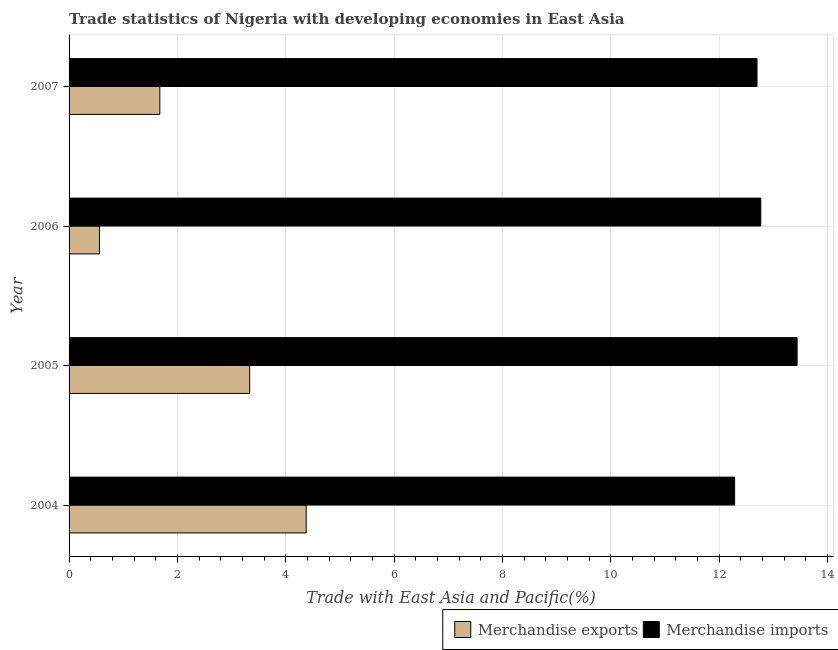How many different coloured bars are there?
Your answer should be compact. 2. How many groups of bars are there?
Provide a succinct answer. 4. Are the number of bars on each tick of the Y-axis equal?
Your answer should be very brief. Yes. How many bars are there on the 1st tick from the top?
Your response must be concise. 2. What is the merchandise imports in 2006?
Your answer should be very brief. 12.77. Across all years, what is the maximum merchandise exports?
Provide a succinct answer. 4.38. Across all years, what is the minimum merchandise imports?
Ensure brevity in your answer.  12.28. What is the total merchandise imports in the graph?
Provide a short and direct response. 51.18. What is the difference between the merchandise exports in 2005 and that in 2006?
Make the answer very short. 2.77. What is the difference between the merchandise imports in 2004 and the merchandise exports in 2005?
Make the answer very short. 8.95. What is the average merchandise exports per year?
Your answer should be very brief. 2.49. In the year 2004, what is the difference between the merchandise imports and merchandise exports?
Offer a very short reply. 7.91. What is the ratio of the merchandise exports in 2004 to that in 2007?
Your answer should be very brief. 2.61. Is the difference between the merchandise exports in 2006 and 2007 greater than the difference between the merchandise imports in 2006 and 2007?
Your answer should be very brief. No. What is the difference between the highest and the second highest merchandise exports?
Offer a terse response. 1.04. What is the difference between the highest and the lowest merchandise imports?
Give a very brief answer. 1.15. In how many years, is the merchandise exports greater than the average merchandise exports taken over all years?
Your answer should be compact. 2. Is the sum of the merchandise exports in 2004 and 2007 greater than the maximum merchandise imports across all years?
Offer a very short reply. No. What does the 2nd bar from the top in 2004 represents?
Make the answer very short. Merchandise exports. Does the graph contain grids?
Provide a succinct answer. Yes. How are the legend labels stacked?
Offer a terse response. Horizontal. What is the title of the graph?
Keep it short and to the point. Trade statistics of Nigeria with developing economies in East Asia. What is the label or title of the X-axis?
Provide a short and direct response. Trade with East Asia and Pacific(%). What is the label or title of the Y-axis?
Your answer should be very brief. Year. What is the Trade with East Asia and Pacific(%) of Merchandise exports in 2004?
Your response must be concise. 4.38. What is the Trade with East Asia and Pacific(%) of Merchandise imports in 2004?
Offer a very short reply. 12.28. What is the Trade with East Asia and Pacific(%) in Merchandise exports in 2005?
Your answer should be compact. 3.33. What is the Trade with East Asia and Pacific(%) in Merchandise imports in 2005?
Make the answer very short. 13.44. What is the Trade with East Asia and Pacific(%) in Merchandise exports in 2006?
Give a very brief answer. 0.56. What is the Trade with East Asia and Pacific(%) in Merchandise imports in 2006?
Offer a very short reply. 12.77. What is the Trade with East Asia and Pacific(%) of Merchandise exports in 2007?
Offer a very short reply. 1.67. What is the Trade with East Asia and Pacific(%) in Merchandise imports in 2007?
Your response must be concise. 12.7. Across all years, what is the maximum Trade with East Asia and Pacific(%) of Merchandise exports?
Offer a terse response. 4.38. Across all years, what is the maximum Trade with East Asia and Pacific(%) of Merchandise imports?
Offer a very short reply. 13.44. Across all years, what is the minimum Trade with East Asia and Pacific(%) of Merchandise exports?
Provide a succinct answer. 0.56. Across all years, what is the minimum Trade with East Asia and Pacific(%) of Merchandise imports?
Give a very brief answer. 12.28. What is the total Trade with East Asia and Pacific(%) in Merchandise exports in the graph?
Your answer should be compact. 9.95. What is the total Trade with East Asia and Pacific(%) of Merchandise imports in the graph?
Offer a very short reply. 51.18. What is the difference between the Trade with East Asia and Pacific(%) of Merchandise exports in 2004 and that in 2005?
Offer a terse response. 1.04. What is the difference between the Trade with East Asia and Pacific(%) of Merchandise imports in 2004 and that in 2005?
Provide a short and direct response. -1.15. What is the difference between the Trade with East Asia and Pacific(%) of Merchandise exports in 2004 and that in 2006?
Make the answer very short. 3.82. What is the difference between the Trade with East Asia and Pacific(%) of Merchandise imports in 2004 and that in 2006?
Keep it short and to the point. -0.48. What is the difference between the Trade with East Asia and Pacific(%) in Merchandise exports in 2004 and that in 2007?
Ensure brevity in your answer.  2.7. What is the difference between the Trade with East Asia and Pacific(%) in Merchandise imports in 2004 and that in 2007?
Provide a short and direct response. -0.41. What is the difference between the Trade with East Asia and Pacific(%) of Merchandise exports in 2005 and that in 2006?
Your response must be concise. 2.77. What is the difference between the Trade with East Asia and Pacific(%) in Merchandise imports in 2005 and that in 2006?
Make the answer very short. 0.67. What is the difference between the Trade with East Asia and Pacific(%) of Merchandise exports in 2005 and that in 2007?
Provide a succinct answer. 1.66. What is the difference between the Trade with East Asia and Pacific(%) in Merchandise imports in 2005 and that in 2007?
Offer a very short reply. 0.74. What is the difference between the Trade with East Asia and Pacific(%) of Merchandise exports in 2006 and that in 2007?
Give a very brief answer. -1.11. What is the difference between the Trade with East Asia and Pacific(%) in Merchandise imports in 2006 and that in 2007?
Your response must be concise. 0.07. What is the difference between the Trade with East Asia and Pacific(%) in Merchandise exports in 2004 and the Trade with East Asia and Pacific(%) in Merchandise imports in 2005?
Keep it short and to the point. -9.06. What is the difference between the Trade with East Asia and Pacific(%) of Merchandise exports in 2004 and the Trade with East Asia and Pacific(%) of Merchandise imports in 2006?
Your answer should be compact. -8.39. What is the difference between the Trade with East Asia and Pacific(%) in Merchandise exports in 2004 and the Trade with East Asia and Pacific(%) in Merchandise imports in 2007?
Make the answer very short. -8.32. What is the difference between the Trade with East Asia and Pacific(%) of Merchandise exports in 2005 and the Trade with East Asia and Pacific(%) of Merchandise imports in 2006?
Make the answer very short. -9.43. What is the difference between the Trade with East Asia and Pacific(%) of Merchandise exports in 2005 and the Trade with East Asia and Pacific(%) of Merchandise imports in 2007?
Ensure brevity in your answer.  -9.36. What is the difference between the Trade with East Asia and Pacific(%) of Merchandise exports in 2006 and the Trade with East Asia and Pacific(%) of Merchandise imports in 2007?
Provide a succinct answer. -12.14. What is the average Trade with East Asia and Pacific(%) of Merchandise exports per year?
Your response must be concise. 2.49. What is the average Trade with East Asia and Pacific(%) in Merchandise imports per year?
Your answer should be compact. 12.8. In the year 2004, what is the difference between the Trade with East Asia and Pacific(%) in Merchandise exports and Trade with East Asia and Pacific(%) in Merchandise imports?
Keep it short and to the point. -7.91. In the year 2005, what is the difference between the Trade with East Asia and Pacific(%) of Merchandise exports and Trade with East Asia and Pacific(%) of Merchandise imports?
Your answer should be compact. -10.1. In the year 2006, what is the difference between the Trade with East Asia and Pacific(%) in Merchandise exports and Trade with East Asia and Pacific(%) in Merchandise imports?
Make the answer very short. -12.21. In the year 2007, what is the difference between the Trade with East Asia and Pacific(%) in Merchandise exports and Trade with East Asia and Pacific(%) in Merchandise imports?
Make the answer very short. -11.02. What is the ratio of the Trade with East Asia and Pacific(%) of Merchandise exports in 2004 to that in 2005?
Give a very brief answer. 1.31. What is the ratio of the Trade with East Asia and Pacific(%) of Merchandise imports in 2004 to that in 2005?
Your response must be concise. 0.91. What is the ratio of the Trade with East Asia and Pacific(%) of Merchandise exports in 2004 to that in 2006?
Your response must be concise. 7.8. What is the ratio of the Trade with East Asia and Pacific(%) of Merchandise imports in 2004 to that in 2006?
Your answer should be very brief. 0.96. What is the ratio of the Trade with East Asia and Pacific(%) in Merchandise exports in 2004 to that in 2007?
Your response must be concise. 2.61. What is the ratio of the Trade with East Asia and Pacific(%) of Merchandise imports in 2004 to that in 2007?
Your answer should be very brief. 0.97. What is the ratio of the Trade with East Asia and Pacific(%) in Merchandise exports in 2005 to that in 2006?
Your answer should be very brief. 5.94. What is the ratio of the Trade with East Asia and Pacific(%) in Merchandise imports in 2005 to that in 2006?
Provide a succinct answer. 1.05. What is the ratio of the Trade with East Asia and Pacific(%) of Merchandise exports in 2005 to that in 2007?
Give a very brief answer. 1.99. What is the ratio of the Trade with East Asia and Pacific(%) in Merchandise imports in 2005 to that in 2007?
Your answer should be compact. 1.06. What is the ratio of the Trade with East Asia and Pacific(%) of Merchandise exports in 2006 to that in 2007?
Provide a succinct answer. 0.33. What is the difference between the highest and the second highest Trade with East Asia and Pacific(%) of Merchandise exports?
Keep it short and to the point. 1.04. What is the difference between the highest and the second highest Trade with East Asia and Pacific(%) in Merchandise imports?
Provide a short and direct response. 0.67. What is the difference between the highest and the lowest Trade with East Asia and Pacific(%) in Merchandise exports?
Your response must be concise. 3.82. What is the difference between the highest and the lowest Trade with East Asia and Pacific(%) in Merchandise imports?
Offer a terse response. 1.15. 